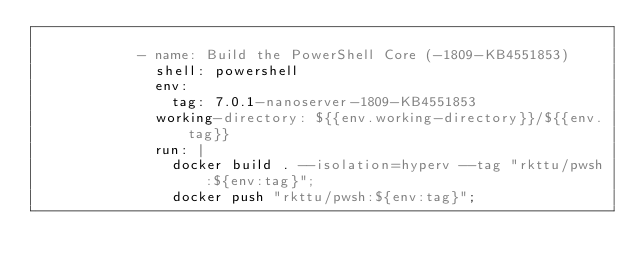<code> <loc_0><loc_0><loc_500><loc_500><_YAML_>
            - name: Build the PowerShell Core (-1809-KB4551853)
              shell: powershell
              env:
                tag: 7.0.1-nanoserver-1809-KB4551853
              working-directory: ${{env.working-directory}}/${{env.tag}}
              run: |
                docker build . --isolation=hyperv --tag "rkttu/pwsh:${env:tag}";
                docker push "rkttu/pwsh:${env:tag}";
</code> 